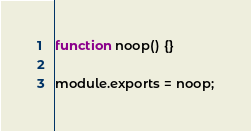<code> <loc_0><loc_0><loc_500><loc_500><_JavaScript_>function noop() {}

module.exports = noop;
</code> 